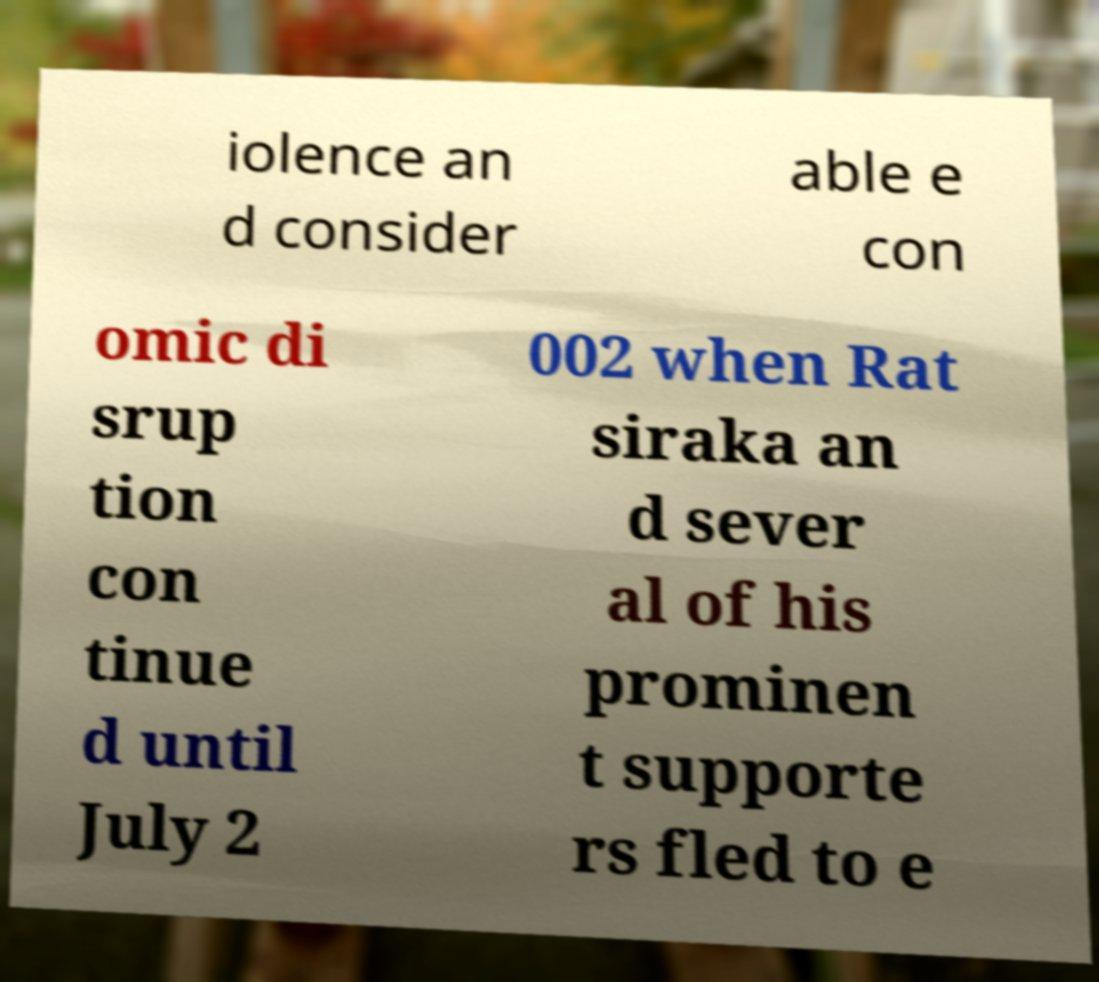Please read and relay the text visible in this image. What does it say? iolence an d consider able e con omic di srup tion con tinue d until July 2 002 when Rat siraka an d sever al of his prominen t supporte rs fled to e 